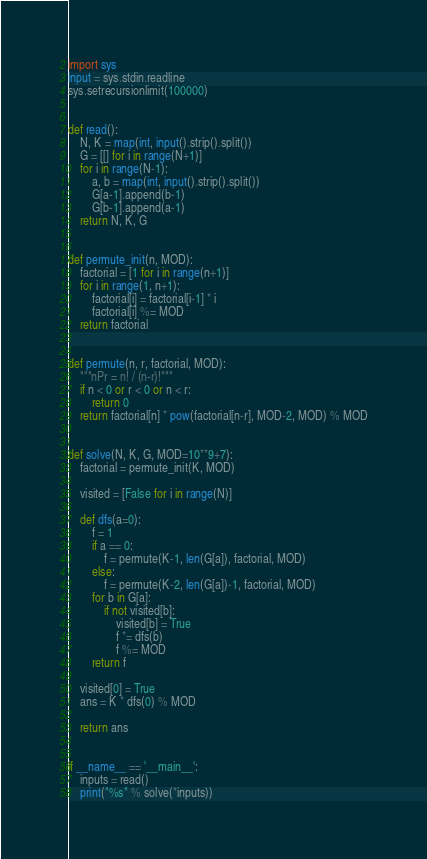<code> <loc_0><loc_0><loc_500><loc_500><_Python_>import sys
input = sys.stdin.readline
sys.setrecursionlimit(100000)


def read():
    N, K = map(int, input().strip().split())
    G = [[] for i in range(N+1)]
    for i in range(N-1):
        a, b = map(int, input().strip().split())
        G[a-1].append(b-1)
        G[b-1].append(a-1)
    return N, K, G


def permute_init(n, MOD):
    factorial = [1 for i in range(n+1)]
    for i in range(1, n+1):
        factorial[i] = factorial[i-1] * i
        factorial[i] %= MOD
    return factorial


def permute(n, r, factorial, MOD):
    """nPr = n! / (n-r)!"""
    if n < 0 or r < 0 or n < r:
        return 0
    return factorial[n] * pow(factorial[n-r], MOD-2, MOD) % MOD


def solve(N, K, G, MOD=10**9+7):
    factorial = permute_init(K, MOD)

    visited = [False for i in range(N)]
    
    def dfs(a=0):
        f = 1
        if a == 0:
            f = permute(K-1, len(G[a]), factorial, MOD)
        else:
            f = permute(K-2, len(G[a])-1, factorial, MOD)
        for b in G[a]:
            if not visited[b]:
                visited[b] = True
                f *= dfs(b)
                f %= MOD
        return f
    
    visited[0] = True
    ans = K * dfs(0) % MOD

    return ans


if __name__ == '__main__':
    inputs = read()
    print("%s" % solve(*inputs))
</code> 